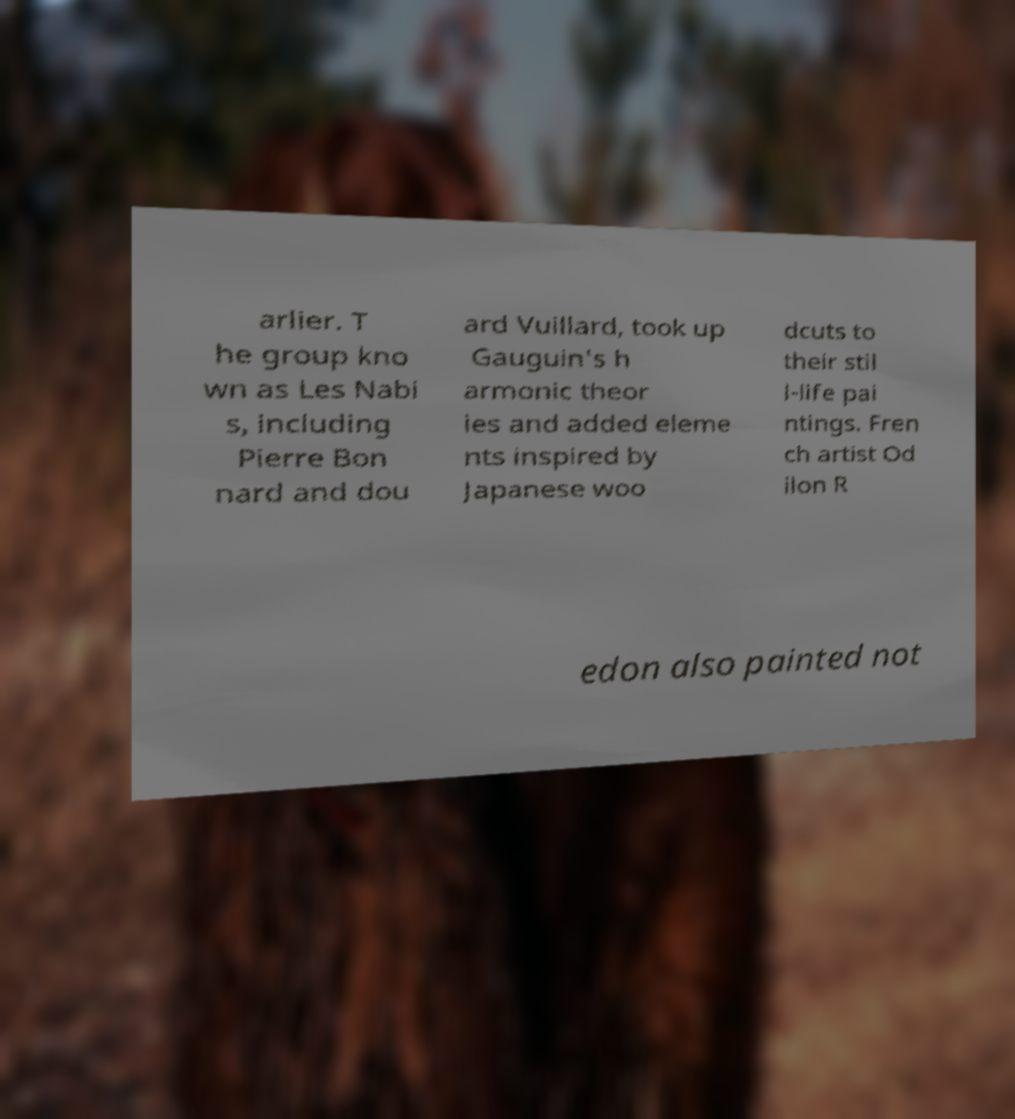For documentation purposes, I need the text within this image transcribed. Could you provide that? arlier. T he group kno wn as Les Nabi s, including Pierre Bon nard and dou ard Vuillard, took up Gauguin's h armonic theor ies and added eleme nts inspired by Japanese woo dcuts to their stil l-life pai ntings. Fren ch artist Od ilon R edon also painted not 